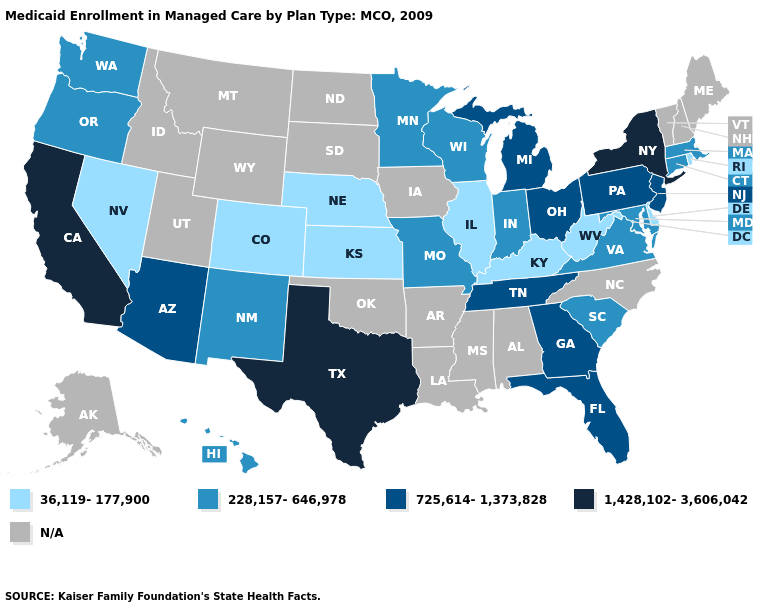Name the states that have a value in the range 36,119-177,900?
Answer briefly. Colorado, Delaware, Illinois, Kansas, Kentucky, Nebraska, Nevada, Rhode Island, West Virginia. What is the value of Michigan?
Quick response, please. 725,614-1,373,828. What is the value of Florida?
Write a very short answer. 725,614-1,373,828. What is the value of Mississippi?
Concise answer only. N/A. Does the map have missing data?
Give a very brief answer. Yes. What is the lowest value in the USA?
Quick response, please. 36,119-177,900. Does the first symbol in the legend represent the smallest category?
Give a very brief answer. Yes. What is the value of Vermont?
Be succinct. N/A. What is the value of Washington?
Give a very brief answer. 228,157-646,978. Name the states that have a value in the range 725,614-1,373,828?
Be succinct. Arizona, Florida, Georgia, Michigan, New Jersey, Ohio, Pennsylvania, Tennessee. What is the lowest value in the USA?
Quick response, please. 36,119-177,900. Does South Carolina have the lowest value in the South?
Concise answer only. No. Which states have the lowest value in the USA?
Concise answer only. Colorado, Delaware, Illinois, Kansas, Kentucky, Nebraska, Nevada, Rhode Island, West Virginia. 